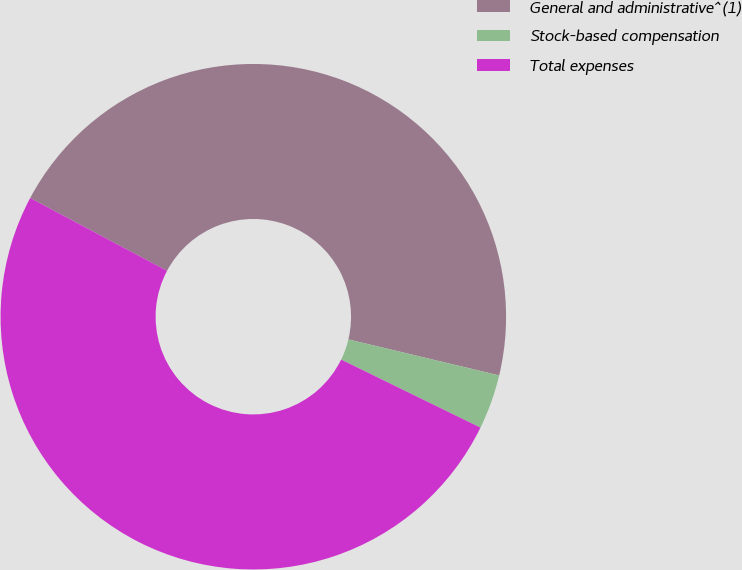Convert chart to OTSL. <chart><loc_0><loc_0><loc_500><loc_500><pie_chart><fcel>General and administrative^(1)<fcel>Stock-based compensation<fcel>Total expenses<nl><fcel>45.95%<fcel>3.5%<fcel>50.55%<nl></chart> 